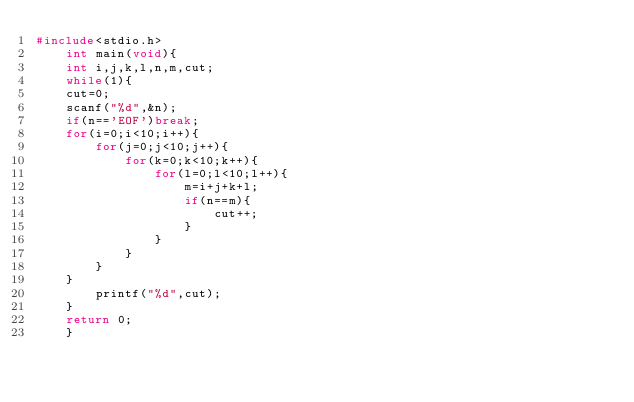<code> <loc_0><loc_0><loc_500><loc_500><_C_>#include<stdio.h>
    int main(void){
    int i,j,k,l,n,m,cut;
    while(1){
    cut=0;
    scanf("%d",&n);
    if(n=='EOF')break;
    for(i=0;i<10;i++){
        for(j=0;j<10;j++){
            for(k=0;k<10;k++){
                for(l=0;l<10;l++){
                    m=i+j+k+l;
                    if(n==m){
                        cut++;
                    }
                }
            }
        }
    }
        printf("%d",cut);
    }
    return 0;
    }</code> 